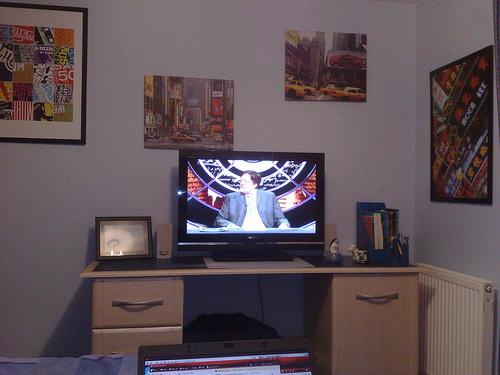Question: how many pictures are hanging on the wall?
Choices:
A. 4.
B. 1.
C. 2.
D. 5.
Answer with the letter. Answer: A Question: what is the television on top of?
Choices:
A. A desk.
B. A table.
C. My bed.
D. Another television.
Answer with the letter. Answer: A Question: how many desk drawers are visible in this picture?
Choices:
A. Four.
B. Three.
C. Two.
D. One.
Answer with the letter. Answer: B Question: what is the device at the bottom of this picture?
Choices:
A. Laptop computer.
B. A computer mouse.
C. A pencil.
D. A calculator.
Answer with the letter. Answer: A 